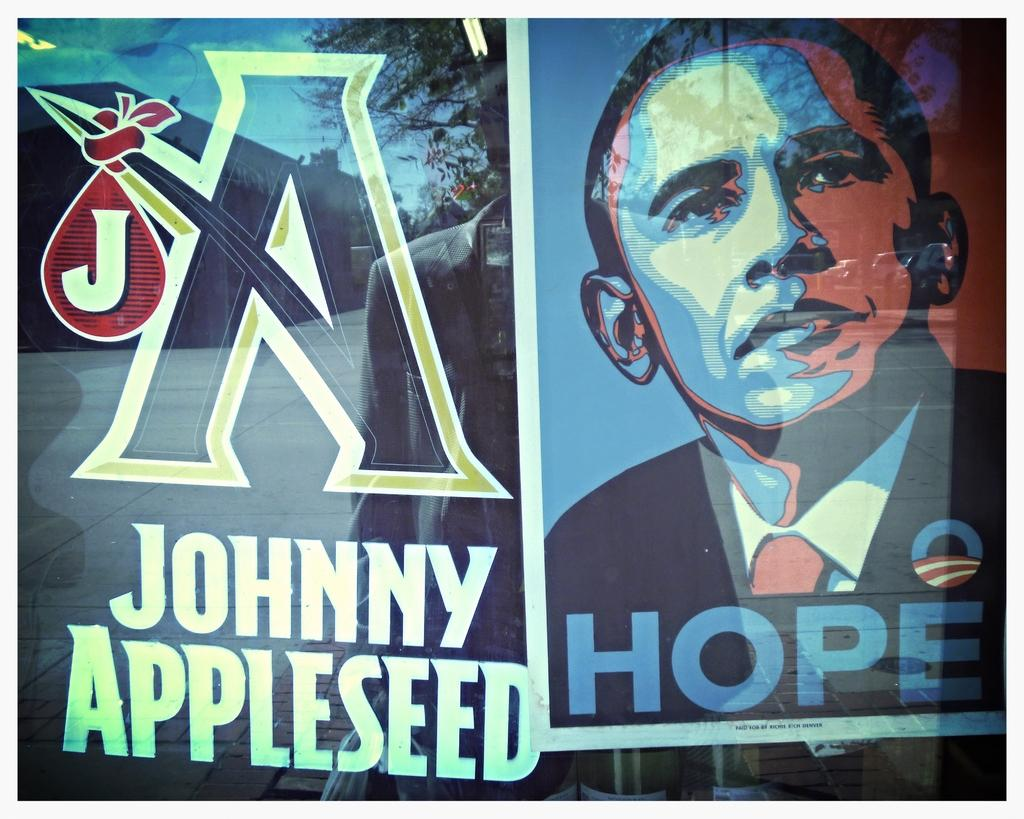What is featured in the image? There is a poster in the image. What can be seen on the glass in the image? There is text on the glass in the image. What is visible in the background of the image? There is a shed, trees, a person, and some objects in the background of the image. What types of surfaces are visible in the image? There is ground and sky visible in the image. What time of day is depicted in the image? The provided facts do not mention the time of day, so it cannot be determined from the image. What type of sheet is covering the person in the background of the image? There is no person covered by a sheet in the image. 